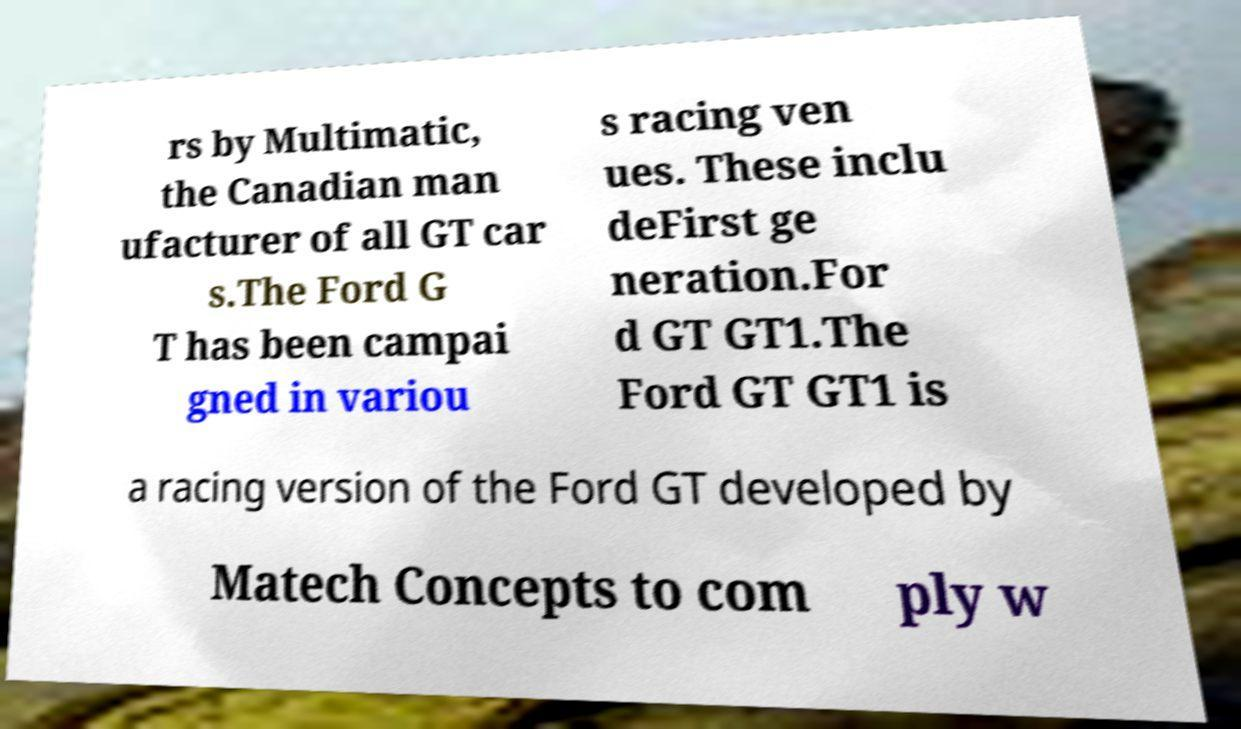There's text embedded in this image that I need extracted. Can you transcribe it verbatim? rs by Multimatic, the Canadian man ufacturer of all GT car s.The Ford G T has been campai gned in variou s racing ven ues. These inclu deFirst ge neration.For d GT GT1.The Ford GT GT1 is a racing version of the Ford GT developed by Matech Concepts to com ply w 